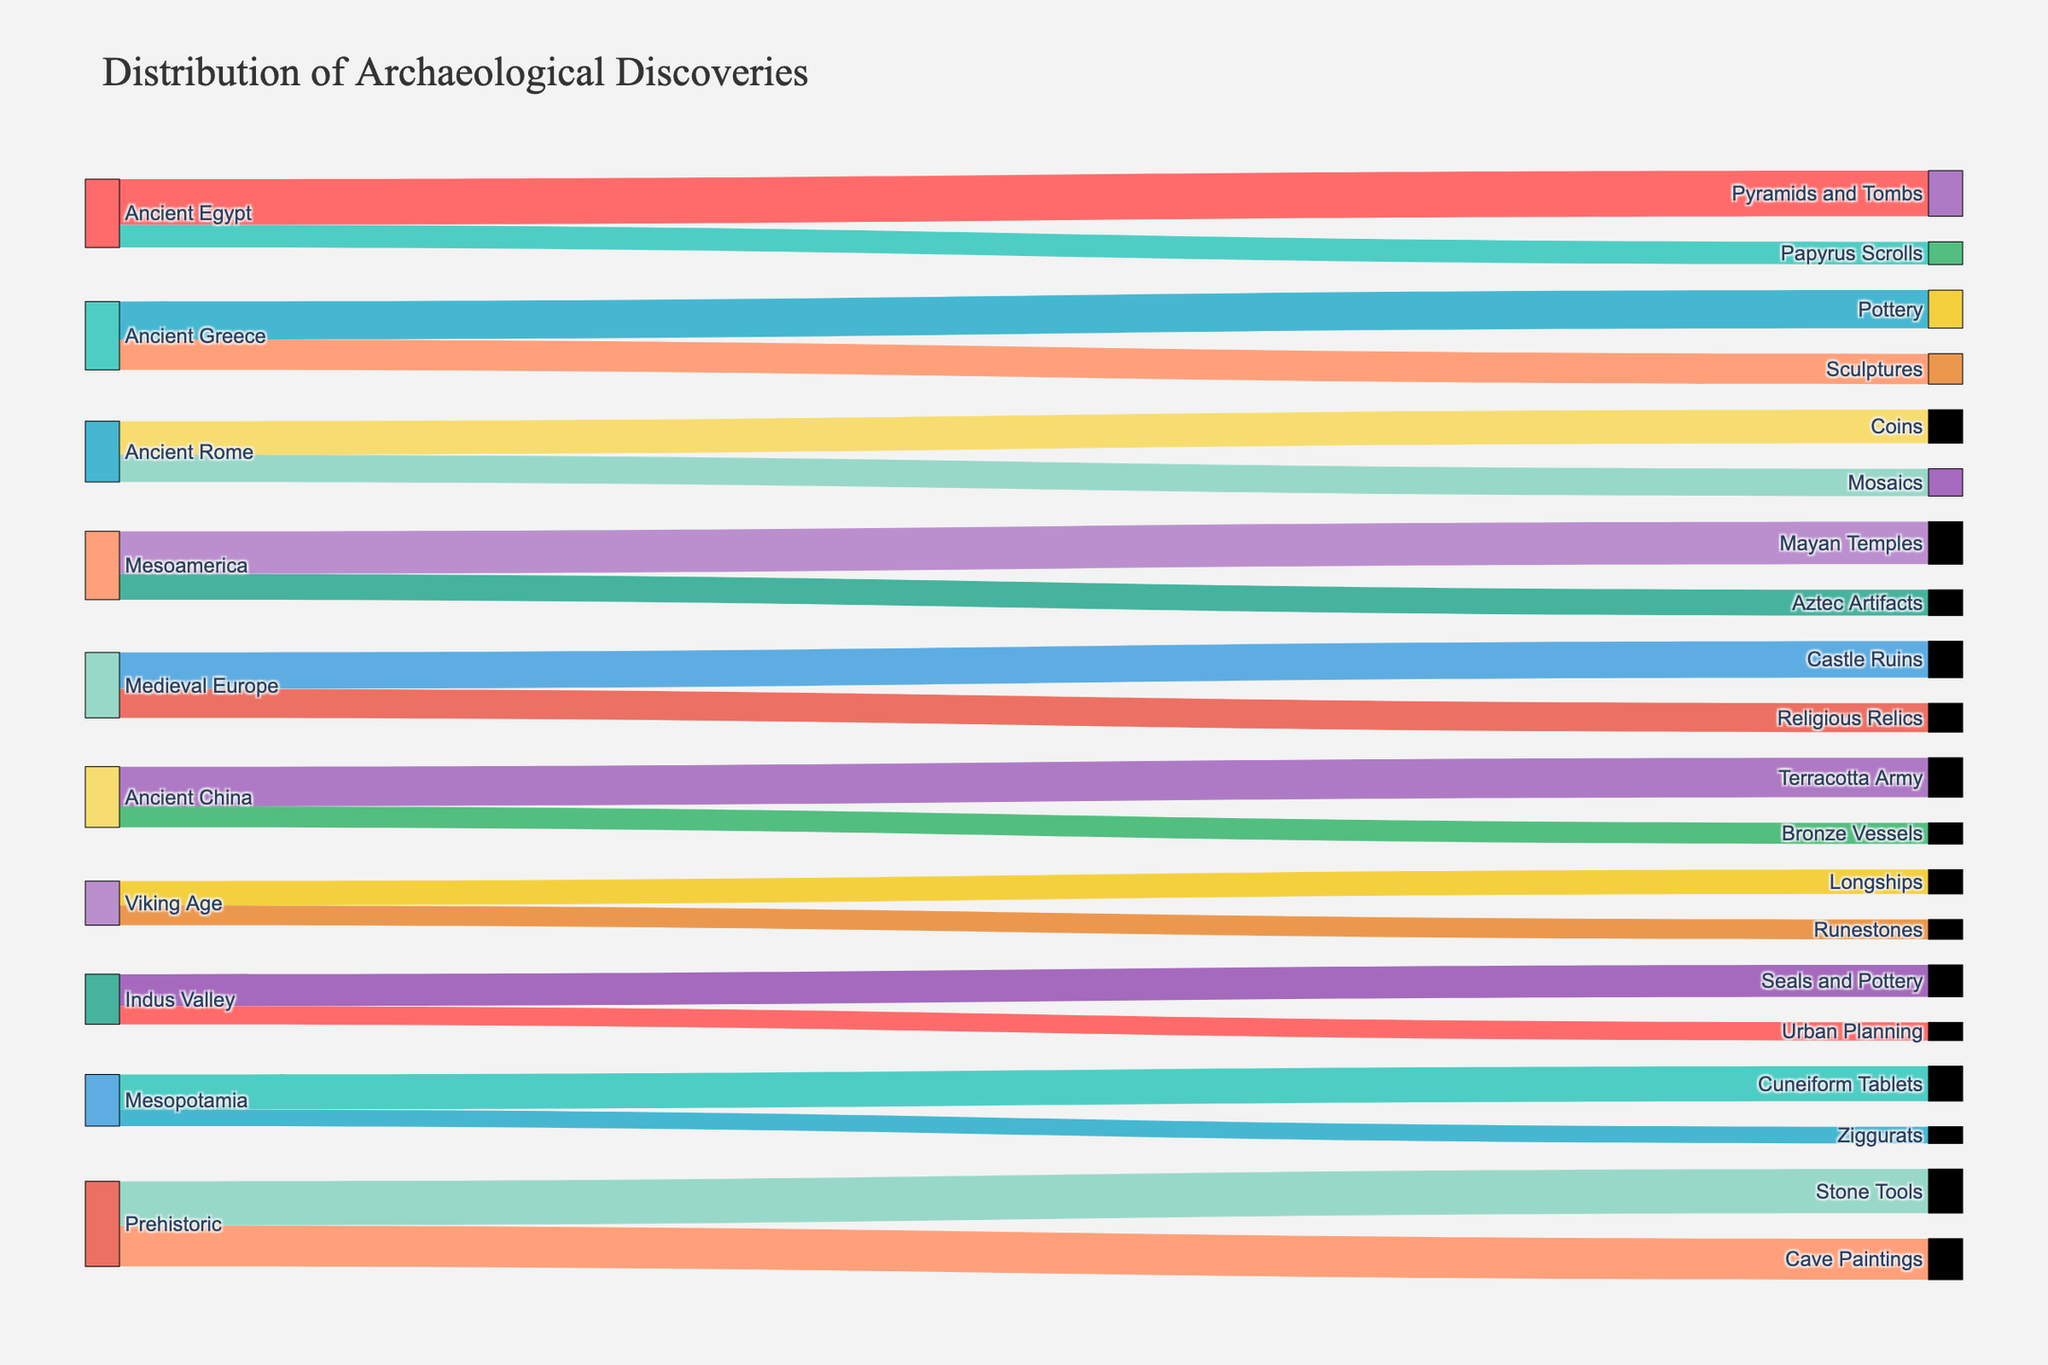what does the title of the figure say? The title of the figure is provided at the top of the chart, which helps in understanding what the figure is about. By looking at the title, you can determine the overall subject of the figure.
Answer: Distribution of Archaeological Discoveries How many types of archaeological discoveries are there in Ancient Egypt? The categories of archaeological discoveries linked to Ancient Egypt are shown by the labels. By identifying and counting the connections emerging from Ancient Egypt, we can determine the number of types.
Answer: 2 Which historical period has the most diverse types of discoveries? To find out which historical period has the most diverse types of discoveries, count the number of distinct target connections for each historical period source. The period with the largest count is the answer.
Answer: Ancient Greece (2 types) What is the value of discoveries linked to the Prehistoric period? To find the value, sum all the values of the archaeological discoveries related to the Prehistoric period by following the figure's links from the source 'Prehistoric' to the various targets.
Answer: 56 (27 + 29) Compare the number of archaeological discoveries between Ancient Greece and Ancient Rome. Which one has more? By comparing the values linked to both Ancient Greece and Ancient Rome, you sum their respective values from the figure to determine which period has more discoveries.
Answer: Ancient Greece (45 vs. 40) What are the regions with the least number of discoveries? By looking at the connections in the figure, identify the regions with the fewest total value of discoveries linked to them. Sum the link values for each region and find the one with the smallest total.
Answer: Indus Valley (33) Which archaeological discovery has the highest individual value? To determine the discovery with the highest value, scan through all target nodes and their associated values in the figure to find the maximum individual value.
Answer: Pyramids and Tombs (30) How many discoveries are shared by the Ancient China period? By counting the outflow of connections from the Ancient China node towards various discoveries, you can determine how many different discoveries are associated with this period.
Answer: 2 Sum the archaeological discovery values for Mesoamerica and compare them to those for Mesopotamia. Which has more? Add the values for discoveries found in Mesoamerica and then do the same for Mesopotamia. Compare the two sums to identify which region has more discoveries.
Answer: Mesoamerica (45 vs. 34) Identify the target node with the fewest connections. By looking at the target nodes and counting how many source connections each has in the figure, the node with the fewest connections can be determined.
Answer: Urban Planning (1) 